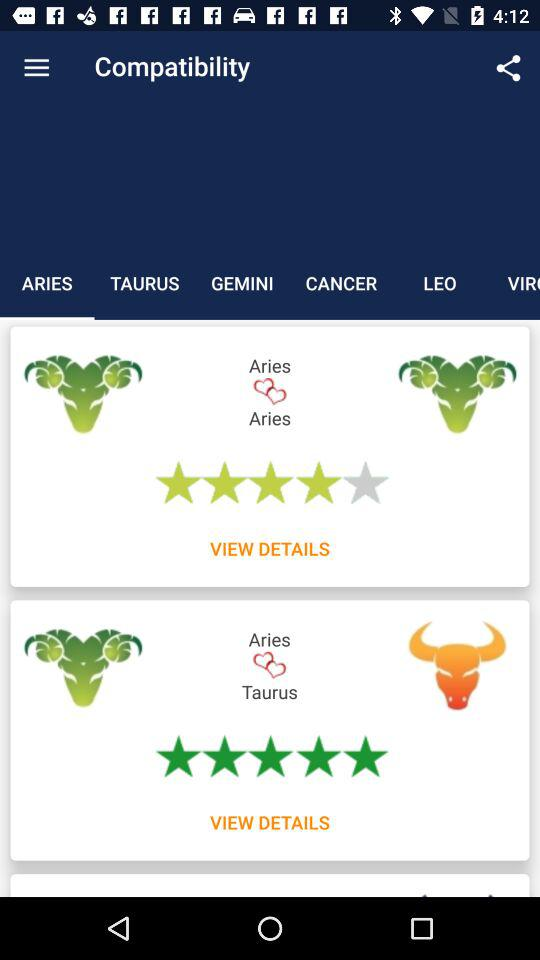How many stars are there for Aries and Aries? There are 4 stars. 